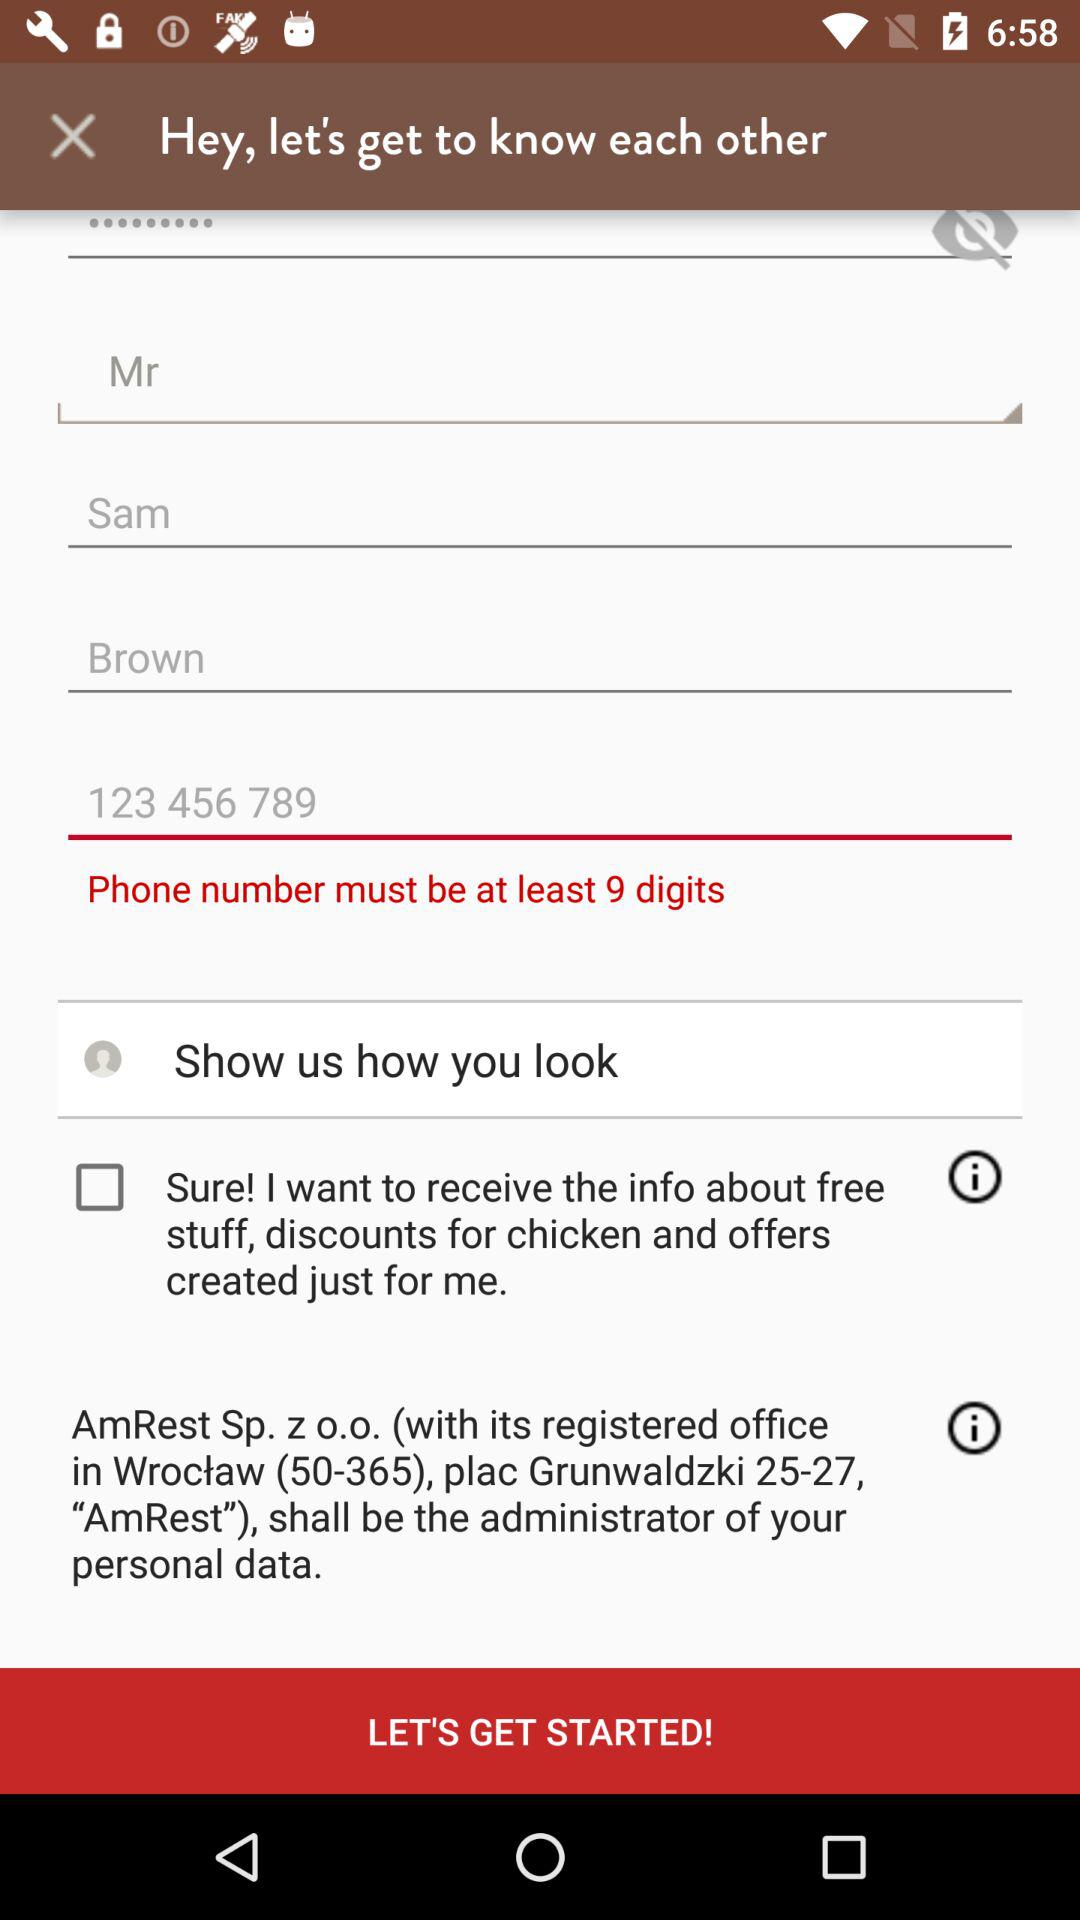What is the first name? The first name is Sam. 